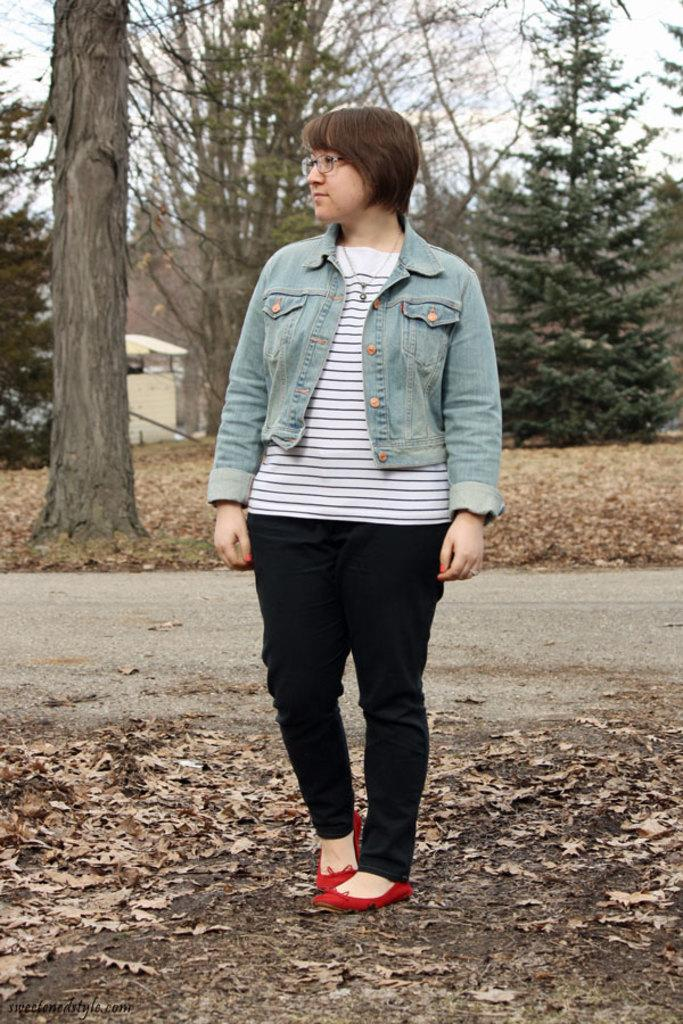Who is present in the image? There is a lady in the image. What is the lady wearing? The lady is wearing a jacket and specs. What is the lady's posture in the image? The lady is standing. What can be seen on the ground in the image? There are dried leaves on the ground. What type of man-made structure is visible in the image? There is a road in the image. What natural elements can be seen in the background of the image? There are trees and the sky visible in the background of the image. What type of building is present in the background of the image? There is a building in the background of the image. What type of quince is being played in the image? There is no quince or any musical instrument present in the image. Can you hear the sound of thunder in the image? The image is a still picture, so there is no sound or thunder present. 